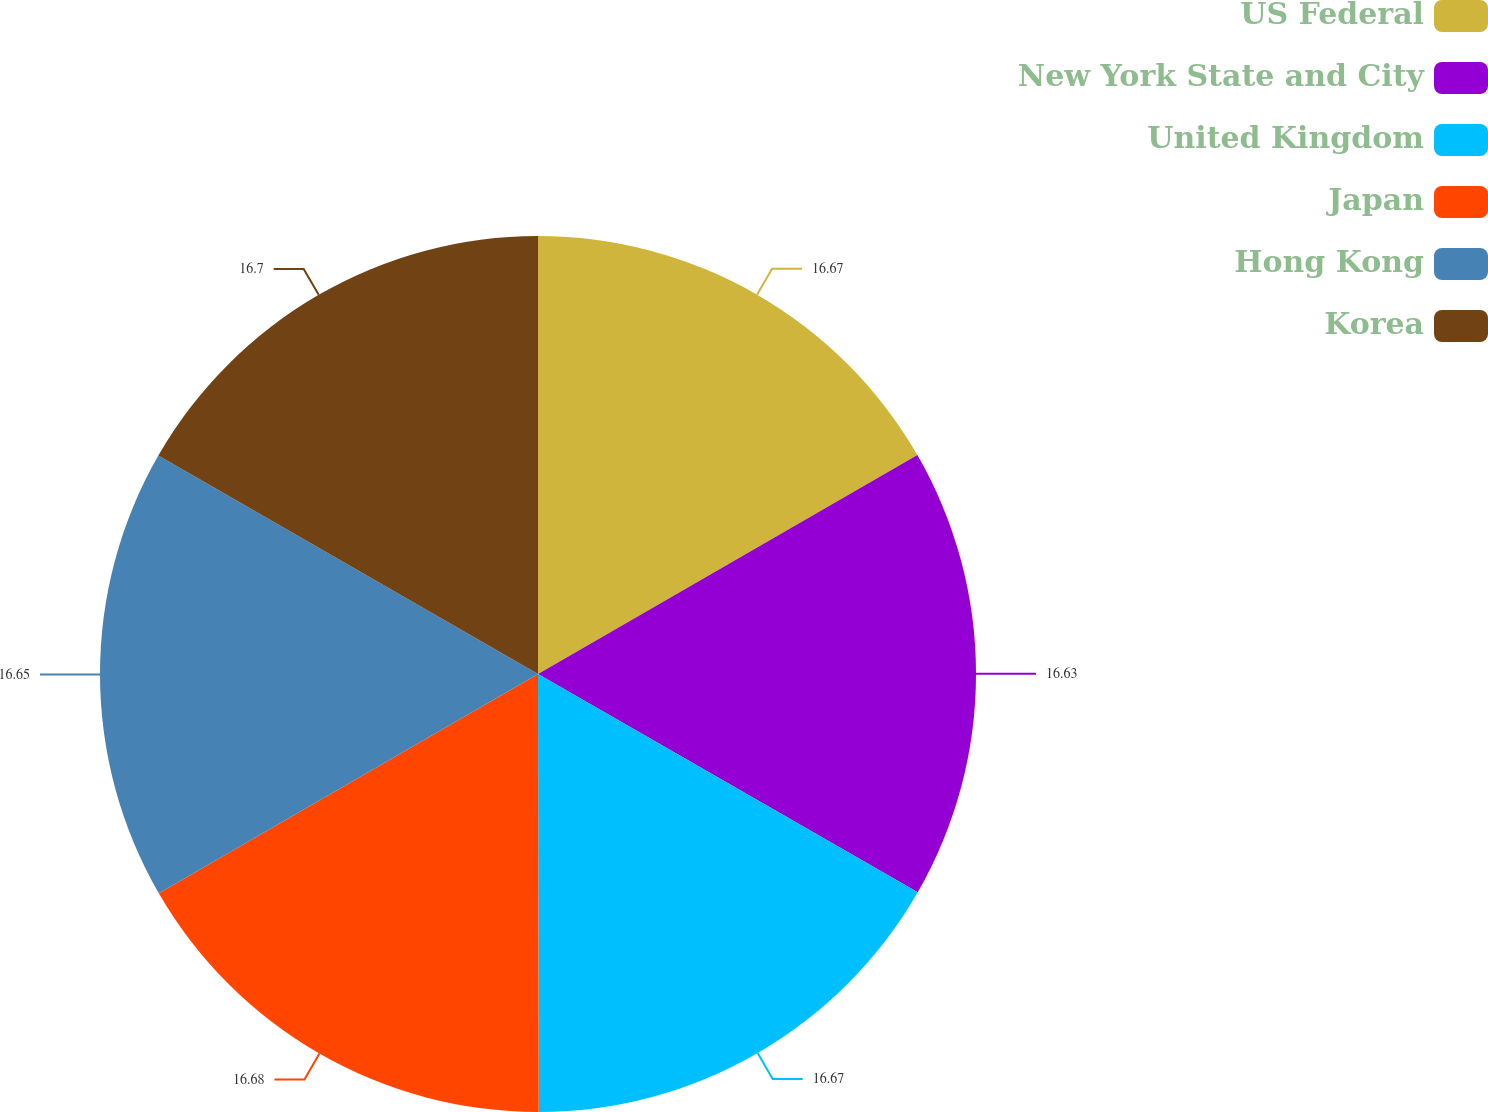<chart> <loc_0><loc_0><loc_500><loc_500><pie_chart><fcel>US Federal<fcel>New York State and City<fcel>United Kingdom<fcel>Japan<fcel>Hong Kong<fcel>Korea<nl><fcel>16.67%<fcel>16.63%<fcel>16.67%<fcel>16.68%<fcel>16.65%<fcel>16.69%<nl></chart> 